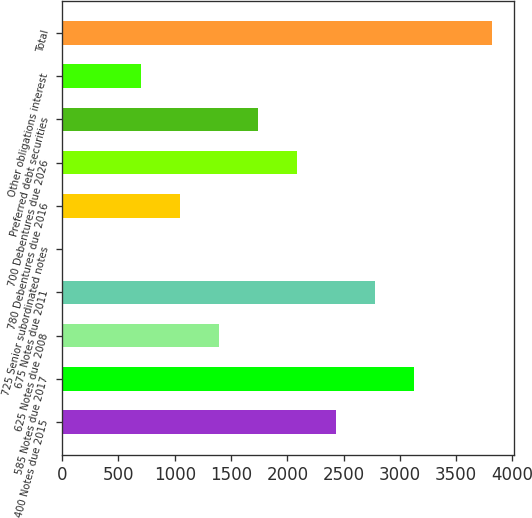<chart> <loc_0><loc_0><loc_500><loc_500><bar_chart><fcel>400 Notes due 2015<fcel>585 Notes due 2017<fcel>625 Notes due 2008<fcel>675 Notes due 2011<fcel>725 Senior subordinated notes<fcel>780 Debentures due 2016<fcel>700 Debentures due 2026<fcel>Preferred debt securities<fcel>Other obligations interest<fcel>Total<nl><fcel>2434.67<fcel>3127.09<fcel>1396.04<fcel>2780.88<fcel>11.2<fcel>1049.83<fcel>2088.46<fcel>1742.25<fcel>703.62<fcel>3819.51<nl></chart> 